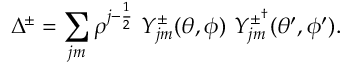<formula> <loc_0><loc_0><loc_500><loc_500>\Delta ^ { \pm } = \sum _ { j m } \rho ^ { j - \frac { 1 } { 2 } } \ Y _ { j m } ^ { \pm } ( \theta , \phi ) \ Y _ { j m } ^ { \pm ^ { \dagger } } ( \theta ^ { \prime } , \phi ^ { \prime } ) .</formula> 